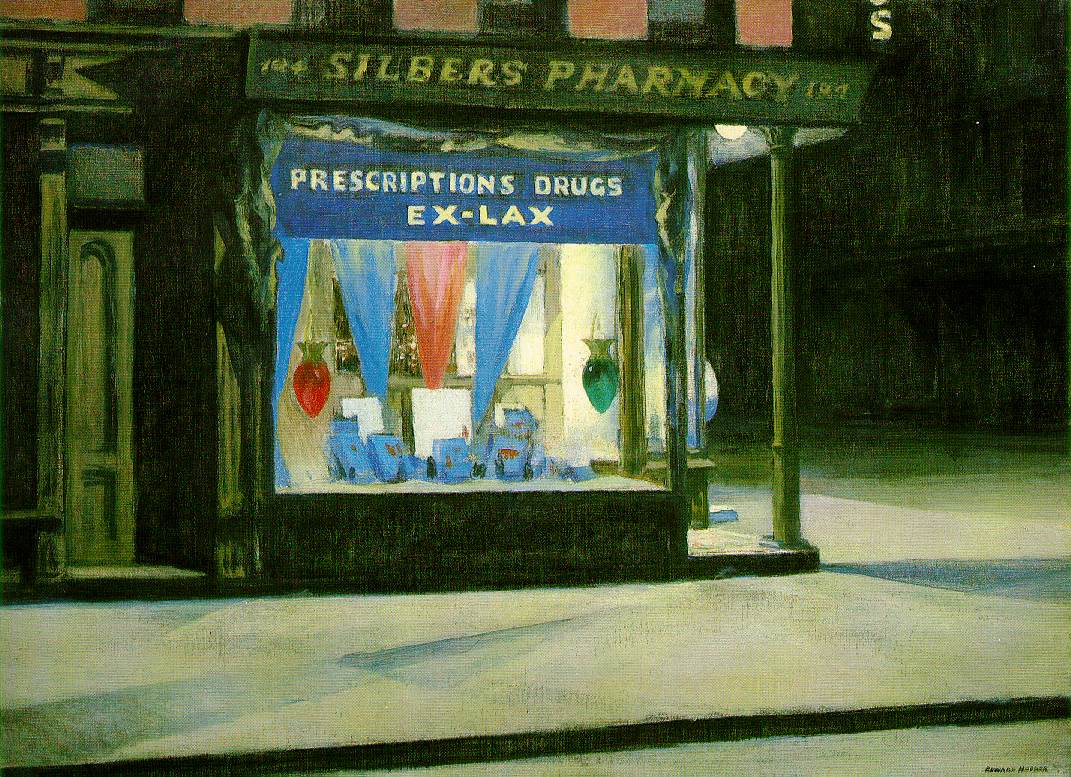Why do you think the street in this painting is empty and void of people? The empty street and absence of people in the painting could be interpreted in several ways. The artist may have chosen this composition to evoke a sense of solitude, quietness, and introspection that is often associated with nighttime. The emptiness might also reflect the nature of urban life during particular hours when bustling streets fall silent, and the hustle of daily life pauses briefly. This lack of human presence might serve to draw more attention to the illuminated pharmacy window, emphasizing the contrast between the warmth and light of human industry and the calm, darkened street surrounding it. It could also suggest a moment of peace and stillness, offering a pause for reflection or highlighting the often-overlooked nighttime beauty of an urban environment. If this scene were to take place during the day, how might it change? If this scene were depicted during the day, several changes could be anticipated. The lighting would be drastically different, with natural daylight brightening the entire scene, diminishing the dramatic play of shadows. The pharmacy sign and window display, which currently stand out against the darkness, might blend more into the overall scene. The mood would likely shift from one of quiet introspection to a more lively, dynamic atmosphere. The street could be populated with pedestrians going about their daily routines, bringing movement and life to the image. The focus might shift from the contemplative solitude of the night to the bustling, interconnectedness of daytime urban life, revealing a different facet of the sharegpt4v/same location. Imagine the pharmacy came to life and had its own character. What kind of personality would it have? If the pharmacy in this painting were anthropomorphized, it might have a character that embodies a blend of wisdom, warmth, and resilience. This pharmacy, a longstanding fixture in the urban landscape, would likely be depicted as a wise old guardian of health, filled with stories of countless individuals it has assisted over the years. It would have a warm, welcoming demeanor, always ready to provide comfort and care to those in need. Its character might also have a touch of nostalgia, reminiscing about the changing times and the people it has seen come and go. Despite the steady flow of time, this pharmacy remains a steady, reassuring presence in the community, embodying resilience and continuity amid the ever-evolving urban environment. 